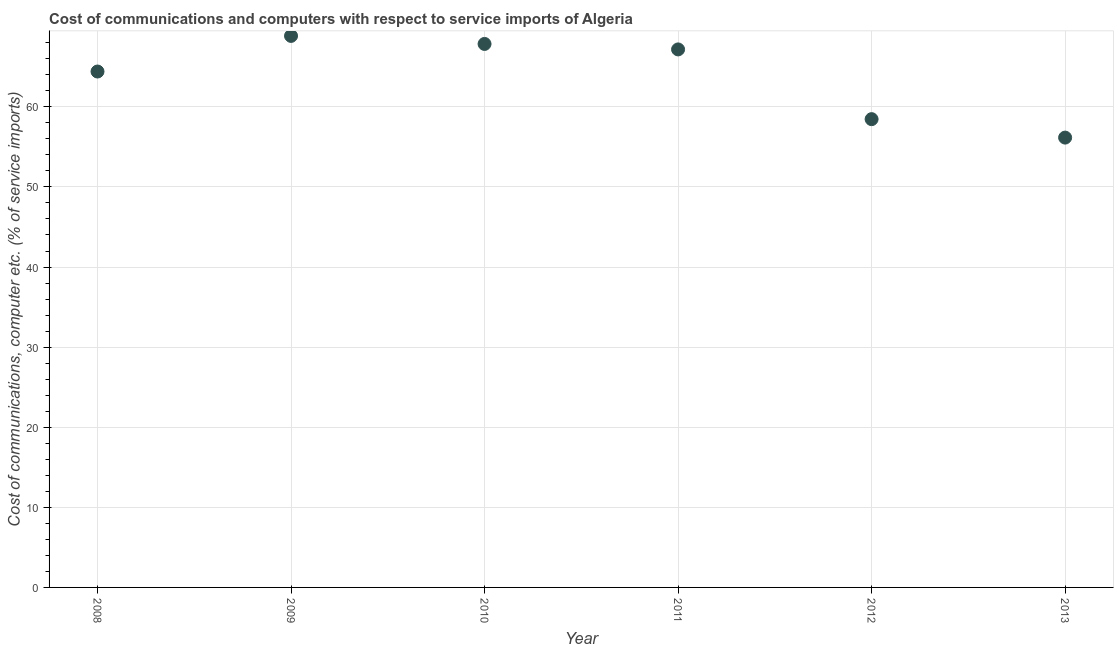What is the cost of communications and computer in 2009?
Keep it short and to the point. 68.86. Across all years, what is the maximum cost of communications and computer?
Offer a terse response. 68.86. Across all years, what is the minimum cost of communications and computer?
Ensure brevity in your answer.  56.16. What is the sum of the cost of communications and computer?
Keep it short and to the point. 382.91. What is the difference between the cost of communications and computer in 2011 and 2012?
Your answer should be very brief. 8.71. What is the average cost of communications and computer per year?
Offer a very short reply. 63.82. What is the median cost of communications and computer?
Your answer should be compact. 65.79. What is the ratio of the cost of communications and computer in 2009 to that in 2010?
Offer a very short reply. 1.01. Is the cost of communications and computer in 2010 less than that in 2013?
Your answer should be very brief. No. Is the difference between the cost of communications and computer in 2010 and 2012 greater than the difference between any two years?
Provide a short and direct response. No. What is the difference between the highest and the second highest cost of communications and computer?
Offer a terse response. 1. What is the difference between the highest and the lowest cost of communications and computer?
Offer a terse response. 12.7. In how many years, is the cost of communications and computer greater than the average cost of communications and computer taken over all years?
Your answer should be very brief. 4. How many dotlines are there?
Make the answer very short. 1. What is the difference between two consecutive major ticks on the Y-axis?
Your answer should be compact. 10. Are the values on the major ticks of Y-axis written in scientific E-notation?
Provide a short and direct response. No. What is the title of the graph?
Offer a terse response. Cost of communications and computers with respect to service imports of Algeria. What is the label or title of the X-axis?
Provide a succinct answer. Year. What is the label or title of the Y-axis?
Provide a short and direct response. Cost of communications, computer etc. (% of service imports). What is the Cost of communications, computer etc. (% of service imports) in 2008?
Offer a terse response. 64.41. What is the Cost of communications, computer etc. (% of service imports) in 2009?
Offer a terse response. 68.86. What is the Cost of communications, computer etc. (% of service imports) in 2010?
Make the answer very short. 67.85. What is the Cost of communications, computer etc. (% of service imports) in 2011?
Offer a very short reply. 67.17. What is the Cost of communications, computer etc. (% of service imports) in 2012?
Provide a short and direct response. 58.46. What is the Cost of communications, computer etc. (% of service imports) in 2013?
Your response must be concise. 56.16. What is the difference between the Cost of communications, computer etc. (% of service imports) in 2008 and 2009?
Make the answer very short. -4.45. What is the difference between the Cost of communications, computer etc. (% of service imports) in 2008 and 2010?
Provide a short and direct response. -3.44. What is the difference between the Cost of communications, computer etc. (% of service imports) in 2008 and 2011?
Ensure brevity in your answer.  -2.76. What is the difference between the Cost of communications, computer etc. (% of service imports) in 2008 and 2012?
Give a very brief answer. 5.95. What is the difference between the Cost of communications, computer etc. (% of service imports) in 2008 and 2013?
Your answer should be compact. 8.25. What is the difference between the Cost of communications, computer etc. (% of service imports) in 2009 and 2010?
Provide a short and direct response. 1. What is the difference between the Cost of communications, computer etc. (% of service imports) in 2009 and 2011?
Make the answer very short. 1.69. What is the difference between the Cost of communications, computer etc. (% of service imports) in 2009 and 2012?
Ensure brevity in your answer.  10.39. What is the difference between the Cost of communications, computer etc. (% of service imports) in 2009 and 2013?
Make the answer very short. 12.7. What is the difference between the Cost of communications, computer etc. (% of service imports) in 2010 and 2011?
Provide a succinct answer. 0.68. What is the difference between the Cost of communications, computer etc. (% of service imports) in 2010 and 2012?
Offer a very short reply. 9.39. What is the difference between the Cost of communications, computer etc. (% of service imports) in 2010 and 2013?
Ensure brevity in your answer.  11.69. What is the difference between the Cost of communications, computer etc. (% of service imports) in 2011 and 2012?
Your answer should be very brief. 8.71. What is the difference between the Cost of communications, computer etc. (% of service imports) in 2011 and 2013?
Make the answer very short. 11.01. What is the difference between the Cost of communications, computer etc. (% of service imports) in 2012 and 2013?
Your response must be concise. 2.3. What is the ratio of the Cost of communications, computer etc. (% of service imports) in 2008 to that in 2009?
Your answer should be very brief. 0.94. What is the ratio of the Cost of communications, computer etc. (% of service imports) in 2008 to that in 2010?
Your answer should be very brief. 0.95. What is the ratio of the Cost of communications, computer etc. (% of service imports) in 2008 to that in 2012?
Your answer should be compact. 1.1. What is the ratio of the Cost of communications, computer etc. (% of service imports) in 2008 to that in 2013?
Provide a succinct answer. 1.15. What is the ratio of the Cost of communications, computer etc. (% of service imports) in 2009 to that in 2010?
Your response must be concise. 1.01. What is the ratio of the Cost of communications, computer etc. (% of service imports) in 2009 to that in 2011?
Offer a very short reply. 1.02. What is the ratio of the Cost of communications, computer etc. (% of service imports) in 2009 to that in 2012?
Ensure brevity in your answer.  1.18. What is the ratio of the Cost of communications, computer etc. (% of service imports) in 2009 to that in 2013?
Ensure brevity in your answer.  1.23. What is the ratio of the Cost of communications, computer etc. (% of service imports) in 2010 to that in 2011?
Offer a very short reply. 1.01. What is the ratio of the Cost of communications, computer etc. (% of service imports) in 2010 to that in 2012?
Your answer should be compact. 1.16. What is the ratio of the Cost of communications, computer etc. (% of service imports) in 2010 to that in 2013?
Your answer should be very brief. 1.21. What is the ratio of the Cost of communications, computer etc. (% of service imports) in 2011 to that in 2012?
Offer a very short reply. 1.15. What is the ratio of the Cost of communications, computer etc. (% of service imports) in 2011 to that in 2013?
Make the answer very short. 1.2. What is the ratio of the Cost of communications, computer etc. (% of service imports) in 2012 to that in 2013?
Your answer should be compact. 1.04. 